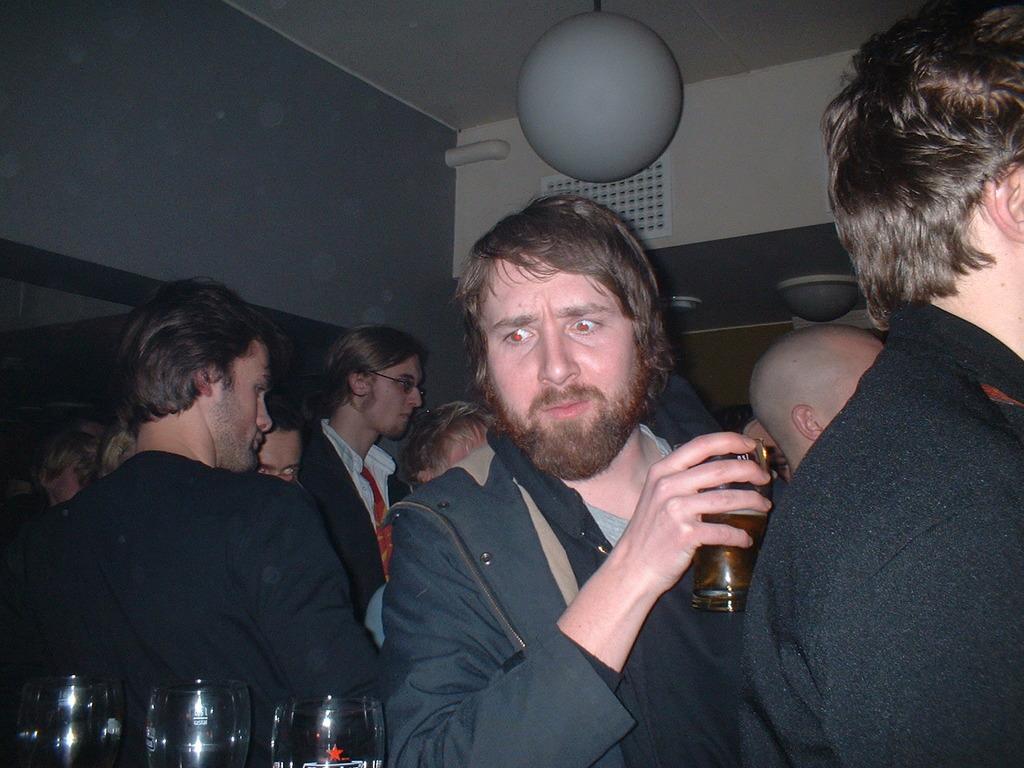Please provide a concise description of this image. In the picture I can see a group of people are standing, among them a man is holding a glass in the hand. I can also see glasses, walls and ceiling. 